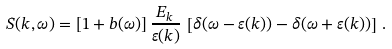<formula> <loc_0><loc_0><loc_500><loc_500>S ( k , \omega ) = [ 1 + b ( \omega ) ] \, \frac { E _ { k } } { \varepsilon ( k ) } \, \left [ \delta ( \omega - \varepsilon ( k ) ) - \delta ( \omega + \varepsilon ( k ) ) \right ] \, .</formula> 